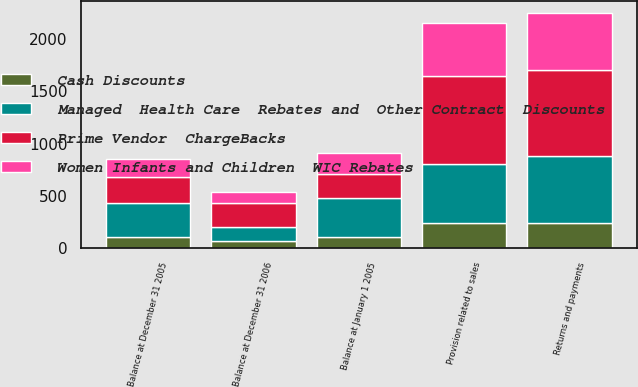Convert chart to OTSL. <chart><loc_0><loc_0><loc_500><loc_500><stacked_bar_chart><ecel><fcel>Balance at January 1 2005<fcel>Provision related to sales<fcel>Returns and payments<fcel>Balance at December 31 2005<fcel>Balance at December 31 2006<nl><fcel>Cash Discounts<fcel>106<fcel>243<fcel>243<fcel>107<fcel>63<nl><fcel>Prime Vendor  ChargeBacks<fcel>234<fcel>843<fcel>825<fcel>252<fcel>230<nl><fcel>Women Infants and Children  WIC Rebates<fcel>198<fcel>509<fcel>542<fcel>167<fcel>111<nl><fcel>Managed  Health Care  Rebates and  Other Contract  Discounts<fcel>372<fcel>558<fcel>641<fcel>326<fcel>137<nl></chart> 